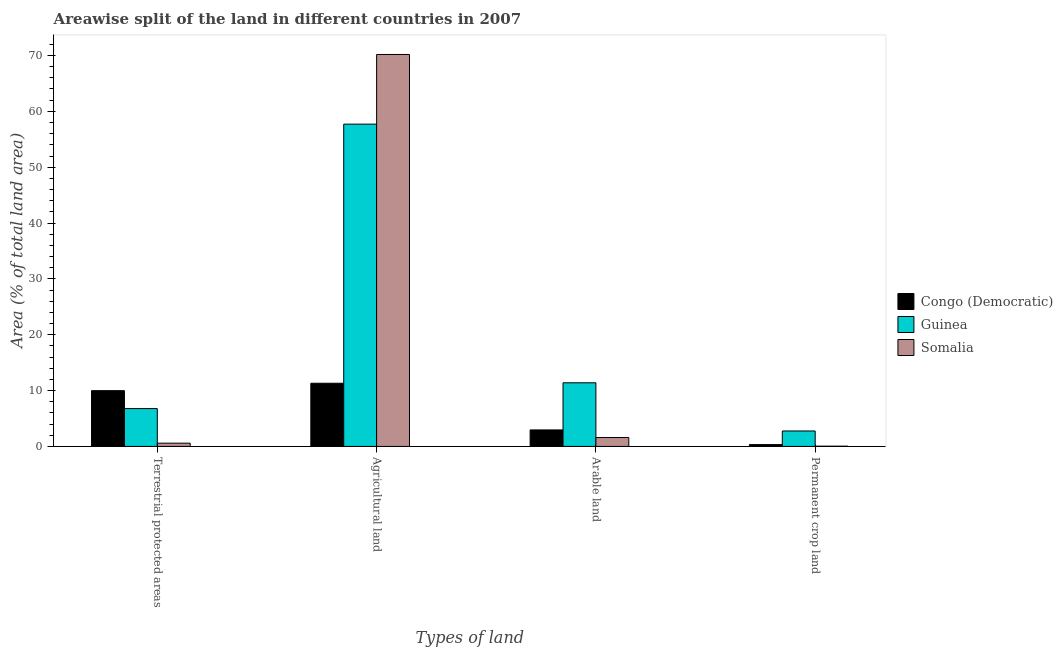Are the number of bars per tick equal to the number of legend labels?
Ensure brevity in your answer.  Yes. Are the number of bars on each tick of the X-axis equal?
Ensure brevity in your answer.  Yes. How many bars are there on the 2nd tick from the right?
Offer a very short reply. 3. What is the label of the 4th group of bars from the left?
Give a very brief answer. Permanent crop land. What is the percentage of land under terrestrial protection in Guinea?
Give a very brief answer. 6.78. Across all countries, what is the maximum percentage of area under arable land?
Keep it short and to the point. 11.4. Across all countries, what is the minimum percentage of area under permanent crop land?
Your answer should be compact. 0.04. In which country was the percentage of area under permanent crop land maximum?
Provide a succinct answer. Guinea. In which country was the percentage of area under arable land minimum?
Your answer should be very brief. Somalia. What is the total percentage of area under agricultural land in the graph?
Provide a succinct answer. 139.2. What is the difference between the percentage of area under agricultural land in Somalia and that in Congo (Democratic)?
Provide a short and direct response. 58.87. What is the difference between the percentage of area under permanent crop land in Guinea and the percentage of area under agricultural land in Congo (Democratic)?
Offer a terse response. -8.55. What is the average percentage of area under arable land per country?
Keep it short and to the point. 5.31. What is the difference between the percentage of area under permanent crop land and percentage of area under arable land in Somalia?
Your answer should be compact. -1.55. In how many countries, is the percentage of area under arable land greater than 68 %?
Your answer should be very brief. 0. What is the ratio of the percentage of area under permanent crop land in Congo (Democratic) to that in Guinea?
Your answer should be very brief. 0.12. Is the percentage of area under arable land in Congo (Democratic) less than that in Somalia?
Your response must be concise. No. Is the difference between the percentage of area under agricultural land in Guinea and Congo (Democratic) greater than the difference between the percentage of area under arable land in Guinea and Congo (Democratic)?
Provide a short and direct response. Yes. What is the difference between the highest and the second highest percentage of area under agricultural land?
Make the answer very short. 12.47. What is the difference between the highest and the lowest percentage of area under permanent crop land?
Your response must be concise. 2.72. What does the 2nd bar from the left in Permanent crop land represents?
Your response must be concise. Guinea. What does the 1st bar from the right in Terrestrial protected areas represents?
Your response must be concise. Somalia. Are all the bars in the graph horizontal?
Offer a terse response. No. How many countries are there in the graph?
Keep it short and to the point. 3. Does the graph contain any zero values?
Offer a terse response. No. Does the graph contain grids?
Keep it short and to the point. No. Where does the legend appear in the graph?
Offer a terse response. Center right. How are the legend labels stacked?
Keep it short and to the point. Vertical. What is the title of the graph?
Ensure brevity in your answer.  Areawise split of the land in different countries in 2007. Does "Equatorial Guinea" appear as one of the legend labels in the graph?
Provide a short and direct response. No. What is the label or title of the X-axis?
Provide a succinct answer. Types of land. What is the label or title of the Y-axis?
Offer a very short reply. Area (% of total land area). What is the Area (% of total land area) of Congo (Democratic) in Terrestrial protected areas?
Offer a very short reply. 9.99. What is the Area (% of total land area) of Guinea in Terrestrial protected areas?
Keep it short and to the point. 6.78. What is the Area (% of total land area) in Somalia in Terrestrial protected areas?
Your response must be concise. 0.58. What is the Area (% of total land area) in Congo (Democratic) in Agricultural land?
Give a very brief answer. 11.31. What is the Area (% of total land area) in Guinea in Agricultural land?
Your answer should be very brief. 57.71. What is the Area (% of total land area) in Somalia in Agricultural land?
Give a very brief answer. 70.18. What is the Area (% of total land area) of Congo (Democratic) in Arable land?
Offer a very short reply. 2.96. What is the Area (% of total land area) in Guinea in Arable land?
Your answer should be compact. 11.4. What is the Area (% of total land area) in Somalia in Arable land?
Offer a terse response. 1.59. What is the Area (% of total land area) of Congo (Democratic) in Permanent crop land?
Ensure brevity in your answer.  0.33. What is the Area (% of total land area) in Guinea in Permanent crop land?
Your answer should be very brief. 2.77. What is the Area (% of total land area) of Somalia in Permanent crop land?
Offer a terse response. 0.04. Across all Types of land, what is the maximum Area (% of total land area) in Congo (Democratic)?
Keep it short and to the point. 11.31. Across all Types of land, what is the maximum Area (% of total land area) in Guinea?
Ensure brevity in your answer.  57.71. Across all Types of land, what is the maximum Area (% of total land area) of Somalia?
Make the answer very short. 70.18. Across all Types of land, what is the minimum Area (% of total land area) in Congo (Democratic)?
Give a very brief answer. 0.33. Across all Types of land, what is the minimum Area (% of total land area) in Guinea?
Your answer should be compact. 2.77. Across all Types of land, what is the minimum Area (% of total land area) in Somalia?
Offer a terse response. 0.04. What is the total Area (% of total land area) in Congo (Democratic) in the graph?
Offer a terse response. 24.59. What is the total Area (% of total land area) of Guinea in the graph?
Offer a very short reply. 78.65. What is the total Area (% of total land area) in Somalia in the graph?
Keep it short and to the point. 72.4. What is the difference between the Area (% of total land area) in Congo (Democratic) in Terrestrial protected areas and that in Agricultural land?
Offer a terse response. -1.33. What is the difference between the Area (% of total land area) of Guinea in Terrestrial protected areas and that in Agricultural land?
Make the answer very short. -50.93. What is the difference between the Area (% of total land area) of Somalia in Terrestrial protected areas and that in Agricultural land?
Offer a very short reply. -69.6. What is the difference between the Area (% of total land area) in Congo (Democratic) in Terrestrial protected areas and that in Arable land?
Provide a short and direct response. 7.03. What is the difference between the Area (% of total land area) of Guinea in Terrestrial protected areas and that in Arable land?
Offer a very short reply. -4.62. What is the difference between the Area (% of total land area) of Somalia in Terrestrial protected areas and that in Arable land?
Provide a succinct answer. -1.01. What is the difference between the Area (% of total land area) of Congo (Democratic) in Terrestrial protected areas and that in Permanent crop land?
Ensure brevity in your answer.  9.66. What is the difference between the Area (% of total land area) of Guinea in Terrestrial protected areas and that in Permanent crop land?
Ensure brevity in your answer.  4.01. What is the difference between the Area (% of total land area) in Somalia in Terrestrial protected areas and that in Permanent crop land?
Provide a succinct answer. 0.54. What is the difference between the Area (% of total land area) of Congo (Democratic) in Agricultural land and that in Arable land?
Provide a succinct answer. 8.36. What is the difference between the Area (% of total land area) of Guinea in Agricultural land and that in Arable land?
Your response must be concise. 46.31. What is the difference between the Area (% of total land area) in Somalia in Agricultural land and that in Arable land?
Your response must be concise. 68.59. What is the difference between the Area (% of total land area) in Congo (Democratic) in Agricultural land and that in Permanent crop land?
Give a very brief answer. 10.98. What is the difference between the Area (% of total land area) in Guinea in Agricultural land and that in Permanent crop land?
Offer a very short reply. 54.94. What is the difference between the Area (% of total land area) of Somalia in Agricultural land and that in Permanent crop land?
Give a very brief answer. 70.14. What is the difference between the Area (% of total land area) in Congo (Democratic) in Arable land and that in Permanent crop land?
Ensure brevity in your answer.  2.62. What is the difference between the Area (% of total land area) in Guinea in Arable land and that in Permanent crop land?
Your response must be concise. 8.63. What is the difference between the Area (% of total land area) of Somalia in Arable land and that in Permanent crop land?
Your answer should be very brief. 1.55. What is the difference between the Area (% of total land area) in Congo (Democratic) in Terrestrial protected areas and the Area (% of total land area) in Guinea in Agricultural land?
Your response must be concise. -47.72. What is the difference between the Area (% of total land area) in Congo (Democratic) in Terrestrial protected areas and the Area (% of total land area) in Somalia in Agricultural land?
Your answer should be compact. -60.19. What is the difference between the Area (% of total land area) of Guinea in Terrestrial protected areas and the Area (% of total land area) of Somalia in Agricultural land?
Provide a short and direct response. -63.41. What is the difference between the Area (% of total land area) in Congo (Democratic) in Terrestrial protected areas and the Area (% of total land area) in Guinea in Arable land?
Offer a very short reply. -1.41. What is the difference between the Area (% of total land area) of Congo (Democratic) in Terrestrial protected areas and the Area (% of total land area) of Somalia in Arable land?
Provide a succinct answer. 8.39. What is the difference between the Area (% of total land area) of Guinea in Terrestrial protected areas and the Area (% of total land area) of Somalia in Arable land?
Offer a very short reply. 5.18. What is the difference between the Area (% of total land area) in Congo (Democratic) in Terrestrial protected areas and the Area (% of total land area) in Guinea in Permanent crop land?
Give a very brief answer. 7.22. What is the difference between the Area (% of total land area) in Congo (Democratic) in Terrestrial protected areas and the Area (% of total land area) in Somalia in Permanent crop land?
Offer a very short reply. 9.94. What is the difference between the Area (% of total land area) in Guinea in Terrestrial protected areas and the Area (% of total land area) in Somalia in Permanent crop land?
Provide a short and direct response. 6.73. What is the difference between the Area (% of total land area) in Congo (Democratic) in Agricultural land and the Area (% of total land area) in Guinea in Arable land?
Provide a succinct answer. -0.08. What is the difference between the Area (% of total land area) of Congo (Democratic) in Agricultural land and the Area (% of total land area) of Somalia in Arable land?
Provide a short and direct response. 9.72. What is the difference between the Area (% of total land area) in Guinea in Agricultural land and the Area (% of total land area) in Somalia in Arable land?
Ensure brevity in your answer.  56.11. What is the difference between the Area (% of total land area) in Congo (Democratic) in Agricultural land and the Area (% of total land area) in Guinea in Permanent crop land?
Ensure brevity in your answer.  8.55. What is the difference between the Area (% of total land area) of Congo (Democratic) in Agricultural land and the Area (% of total land area) of Somalia in Permanent crop land?
Your answer should be compact. 11.27. What is the difference between the Area (% of total land area) of Guinea in Agricultural land and the Area (% of total land area) of Somalia in Permanent crop land?
Provide a succinct answer. 57.66. What is the difference between the Area (% of total land area) in Congo (Democratic) in Arable land and the Area (% of total land area) in Guinea in Permanent crop land?
Keep it short and to the point. 0.19. What is the difference between the Area (% of total land area) of Congo (Democratic) in Arable land and the Area (% of total land area) of Somalia in Permanent crop land?
Give a very brief answer. 2.91. What is the difference between the Area (% of total land area) in Guinea in Arable land and the Area (% of total land area) in Somalia in Permanent crop land?
Provide a succinct answer. 11.35. What is the average Area (% of total land area) in Congo (Democratic) per Types of land?
Give a very brief answer. 6.15. What is the average Area (% of total land area) in Guinea per Types of land?
Ensure brevity in your answer.  19.66. What is the average Area (% of total land area) in Somalia per Types of land?
Provide a short and direct response. 18.1. What is the difference between the Area (% of total land area) in Congo (Democratic) and Area (% of total land area) in Guinea in Terrestrial protected areas?
Make the answer very short. 3.21. What is the difference between the Area (% of total land area) in Congo (Democratic) and Area (% of total land area) in Somalia in Terrestrial protected areas?
Your answer should be compact. 9.4. What is the difference between the Area (% of total land area) of Guinea and Area (% of total land area) of Somalia in Terrestrial protected areas?
Give a very brief answer. 6.19. What is the difference between the Area (% of total land area) of Congo (Democratic) and Area (% of total land area) of Guinea in Agricultural land?
Your answer should be very brief. -46.39. What is the difference between the Area (% of total land area) in Congo (Democratic) and Area (% of total land area) in Somalia in Agricultural land?
Provide a short and direct response. -58.87. What is the difference between the Area (% of total land area) in Guinea and Area (% of total land area) in Somalia in Agricultural land?
Provide a succinct answer. -12.47. What is the difference between the Area (% of total land area) in Congo (Democratic) and Area (% of total land area) in Guinea in Arable land?
Provide a succinct answer. -8.44. What is the difference between the Area (% of total land area) of Congo (Democratic) and Area (% of total land area) of Somalia in Arable land?
Make the answer very short. 1.36. What is the difference between the Area (% of total land area) in Guinea and Area (% of total land area) in Somalia in Arable land?
Offer a terse response. 9.8. What is the difference between the Area (% of total land area) of Congo (Democratic) and Area (% of total land area) of Guinea in Permanent crop land?
Offer a terse response. -2.44. What is the difference between the Area (% of total land area) in Congo (Democratic) and Area (% of total land area) in Somalia in Permanent crop land?
Provide a short and direct response. 0.29. What is the difference between the Area (% of total land area) in Guinea and Area (% of total land area) in Somalia in Permanent crop land?
Your answer should be very brief. 2.72. What is the ratio of the Area (% of total land area) in Congo (Democratic) in Terrestrial protected areas to that in Agricultural land?
Give a very brief answer. 0.88. What is the ratio of the Area (% of total land area) in Guinea in Terrestrial protected areas to that in Agricultural land?
Make the answer very short. 0.12. What is the ratio of the Area (% of total land area) in Somalia in Terrestrial protected areas to that in Agricultural land?
Your answer should be compact. 0.01. What is the ratio of the Area (% of total land area) in Congo (Democratic) in Terrestrial protected areas to that in Arable land?
Give a very brief answer. 3.38. What is the ratio of the Area (% of total land area) in Guinea in Terrestrial protected areas to that in Arable land?
Give a very brief answer. 0.59. What is the ratio of the Area (% of total land area) in Somalia in Terrestrial protected areas to that in Arable land?
Make the answer very short. 0.37. What is the ratio of the Area (% of total land area) of Congo (Democratic) in Terrestrial protected areas to that in Permanent crop land?
Ensure brevity in your answer.  30.19. What is the ratio of the Area (% of total land area) in Guinea in Terrestrial protected areas to that in Permanent crop land?
Your response must be concise. 2.45. What is the ratio of the Area (% of total land area) in Somalia in Terrestrial protected areas to that in Permanent crop land?
Your response must be concise. 13.08. What is the ratio of the Area (% of total land area) in Congo (Democratic) in Agricultural land to that in Arable land?
Your answer should be very brief. 3.83. What is the ratio of the Area (% of total land area) in Guinea in Agricultural land to that in Arable land?
Provide a succinct answer. 5.06. What is the ratio of the Area (% of total land area) in Somalia in Agricultural land to that in Arable land?
Your answer should be very brief. 44.03. What is the ratio of the Area (% of total land area) in Congo (Democratic) in Agricultural land to that in Permanent crop land?
Your answer should be very brief. 34.2. What is the ratio of the Area (% of total land area) in Guinea in Agricultural land to that in Permanent crop land?
Provide a succinct answer. 20.85. What is the ratio of the Area (% of total land area) in Somalia in Agricultural land to that in Permanent crop land?
Offer a terse response. 1572.43. What is the ratio of the Area (% of total land area) of Congo (Democratic) in Arable land to that in Permanent crop land?
Give a very brief answer. 8.93. What is the ratio of the Area (% of total land area) of Guinea in Arable land to that in Permanent crop land?
Offer a very short reply. 4.12. What is the ratio of the Area (% of total land area) of Somalia in Arable land to that in Permanent crop land?
Provide a succinct answer. 35.71. What is the difference between the highest and the second highest Area (% of total land area) of Congo (Democratic)?
Offer a very short reply. 1.33. What is the difference between the highest and the second highest Area (% of total land area) of Guinea?
Keep it short and to the point. 46.31. What is the difference between the highest and the second highest Area (% of total land area) of Somalia?
Offer a very short reply. 68.59. What is the difference between the highest and the lowest Area (% of total land area) in Congo (Democratic)?
Ensure brevity in your answer.  10.98. What is the difference between the highest and the lowest Area (% of total land area) in Guinea?
Make the answer very short. 54.94. What is the difference between the highest and the lowest Area (% of total land area) in Somalia?
Offer a very short reply. 70.14. 